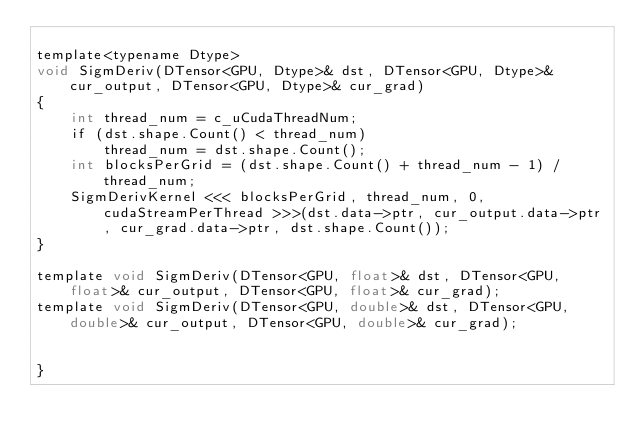Convert code to text. <code><loc_0><loc_0><loc_500><loc_500><_Cuda_>
template<typename Dtype>
void SigmDeriv(DTensor<GPU, Dtype>& dst, DTensor<GPU, Dtype>& cur_output, DTensor<GPU, Dtype>& cur_grad)
{
	int thread_num = c_uCudaThreadNum;
	if (dst.shape.Count() < thread_num)
		thread_num = dst.shape.Count();
    int blocksPerGrid = (dst.shape.Count() + thread_num - 1) / thread_num;
    SigmDerivKernel <<< blocksPerGrid, thread_num, 0, cudaStreamPerThread >>>(dst.data->ptr, cur_output.data->ptr, cur_grad.data->ptr, dst.shape.Count());
}

template void SigmDeriv(DTensor<GPU, float>& dst, DTensor<GPU, float>& cur_output, DTensor<GPU, float>& cur_grad);
template void SigmDeriv(DTensor<GPU, double>& dst, DTensor<GPU, double>& cur_output, DTensor<GPU, double>& cur_grad);


}</code> 